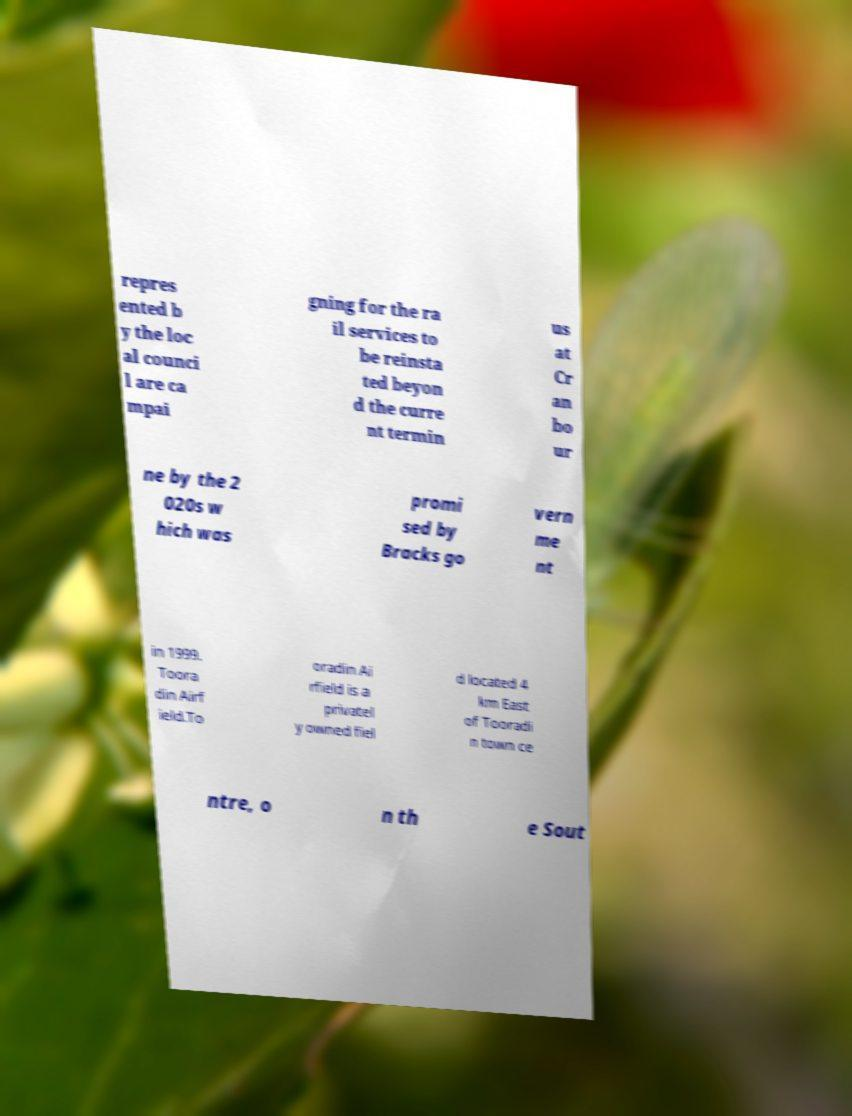There's text embedded in this image that I need extracted. Can you transcribe it verbatim? repres ented b y the loc al counci l are ca mpai gning for the ra il services to be reinsta ted beyon d the curre nt termin us at Cr an bo ur ne by the 2 020s w hich was promi sed by Bracks go vern me nt in 1999. Toora din Airf ield.To oradin Ai rfield is a privatel y owned fiel d located 4 km East of Tooradi n town ce ntre, o n th e Sout 